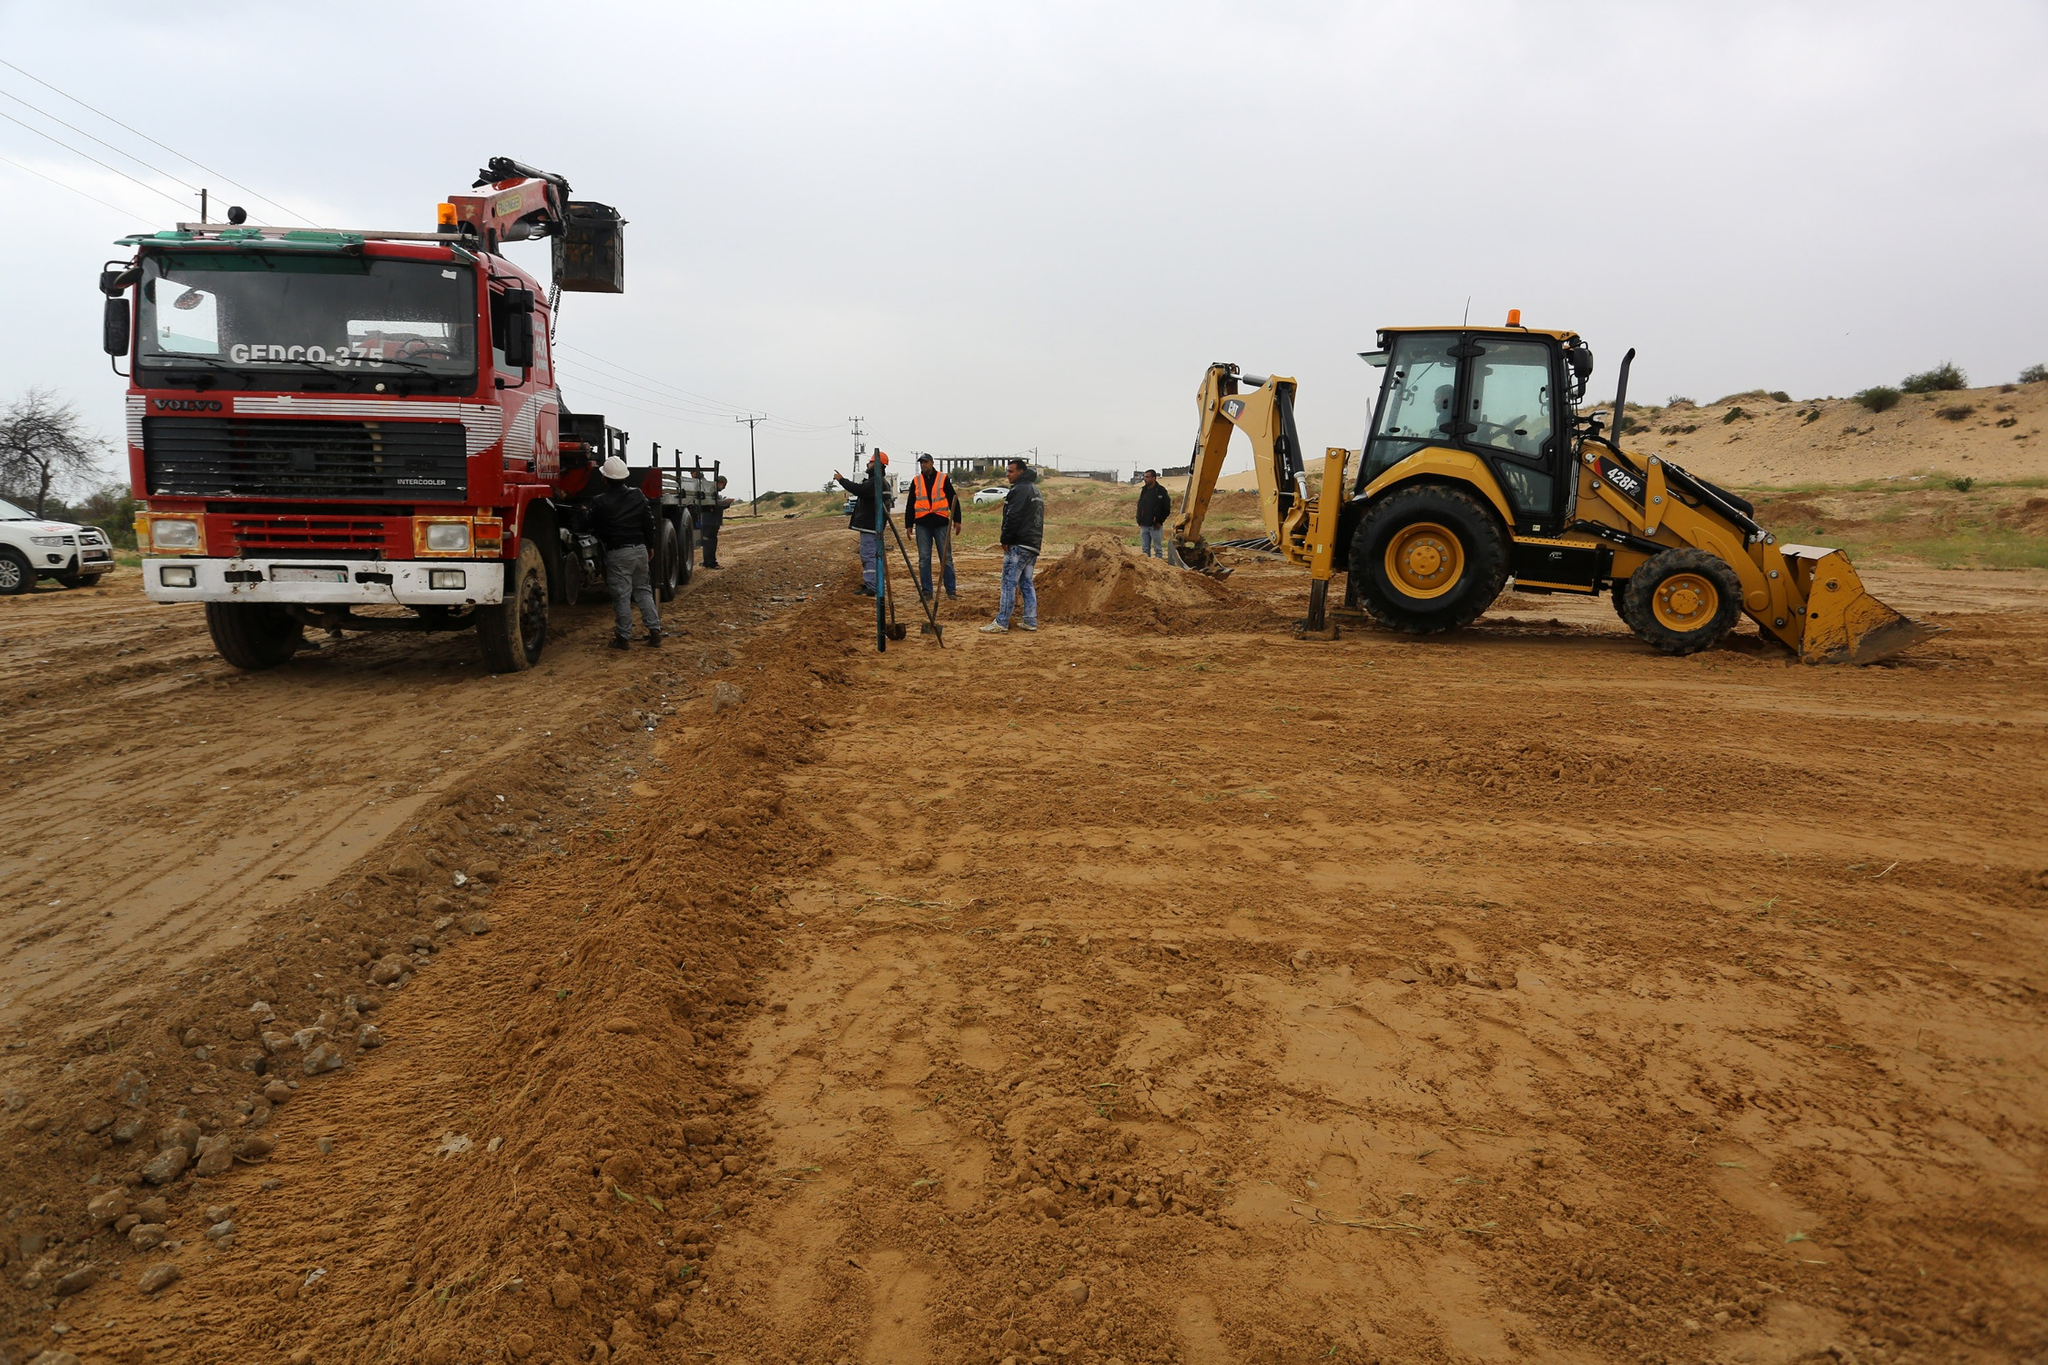What kind of challenges might these workers face on this project? Challenges on such a construction project could range from technical issues with the machinery to unexpected weather conditions that might hinder progress. They might encounter difficulties in soil stability, requiring careful planning and additional resources to ensure a stable foundation. There’s also the potential for logistical challenges, such as coordinating the machinery’s movements or managing site access for supply deliveries. Ensuring worker safety amidst the heavy equipment is paramount, requiring constant vigilance and adherence to safety protocols. 